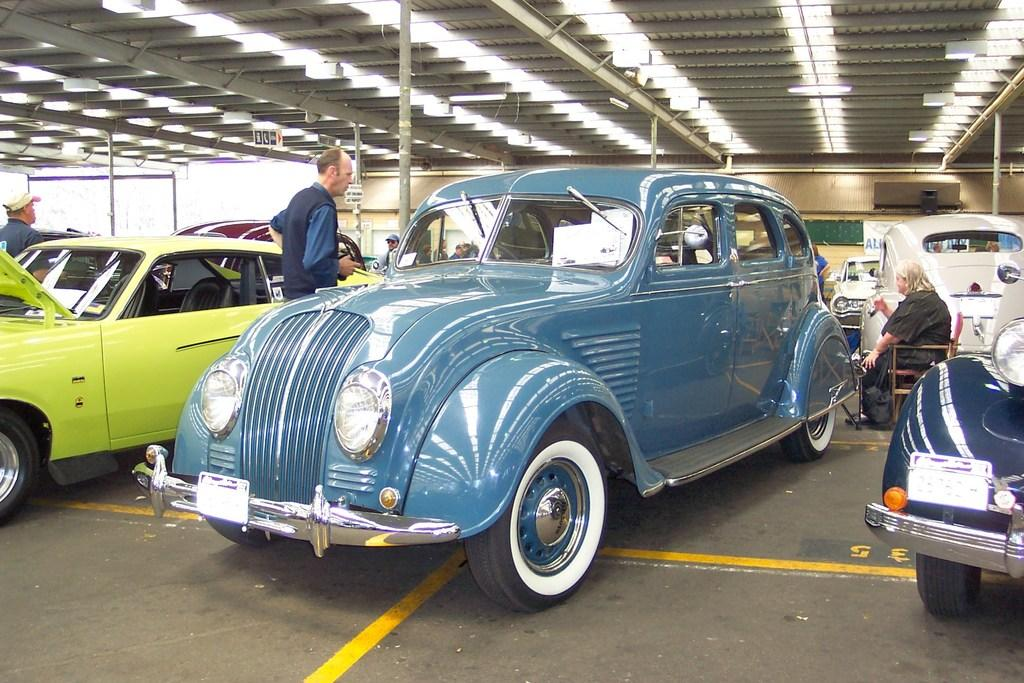What type of structure is visible in the image? There is a shed in the image. Who or what is located under the shed? There are persons and vehicles under the shed. Are there any additional features attached to the shed? Yes, there are lights attached to the roof of the shed. What type of cloth is being used by the police in the image? There is no mention of police or any cloth in the image. 